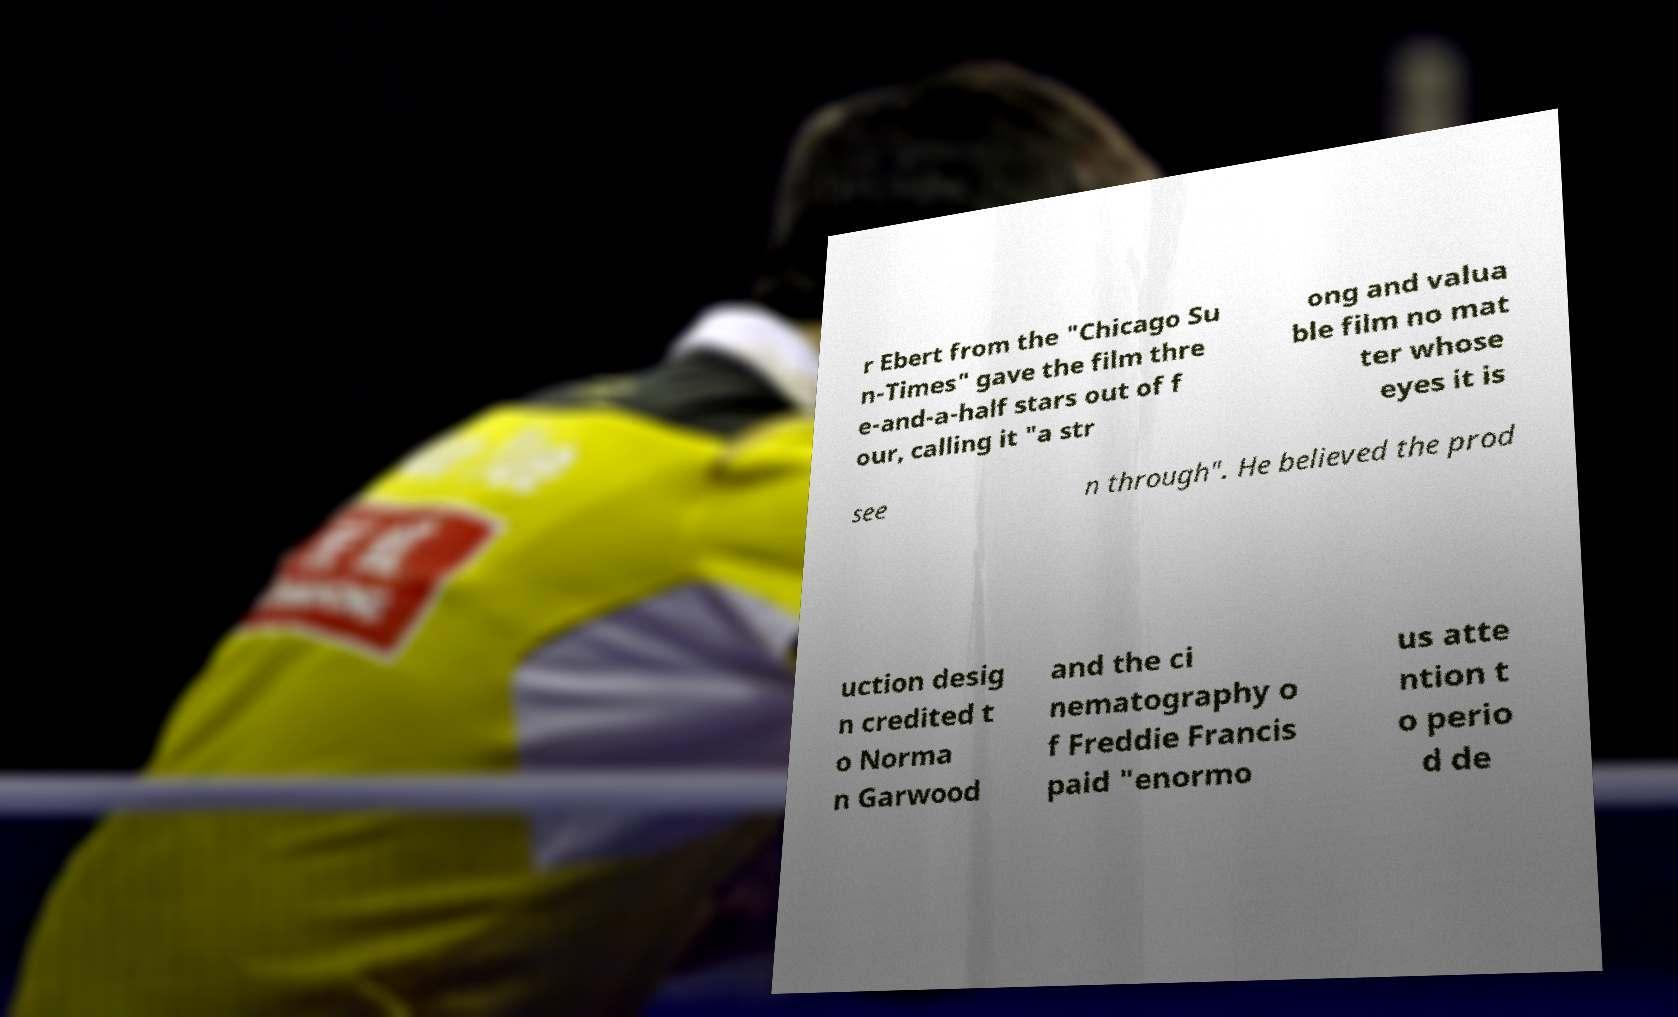For documentation purposes, I need the text within this image transcribed. Could you provide that? r Ebert from the "Chicago Su n-Times" gave the film thre e-and-a-half stars out of f our, calling it "a str ong and valua ble film no mat ter whose eyes it is see n through". He believed the prod uction desig n credited t o Norma n Garwood and the ci nematography o f Freddie Francis paid "enormo us atte ntion t o perio d de 